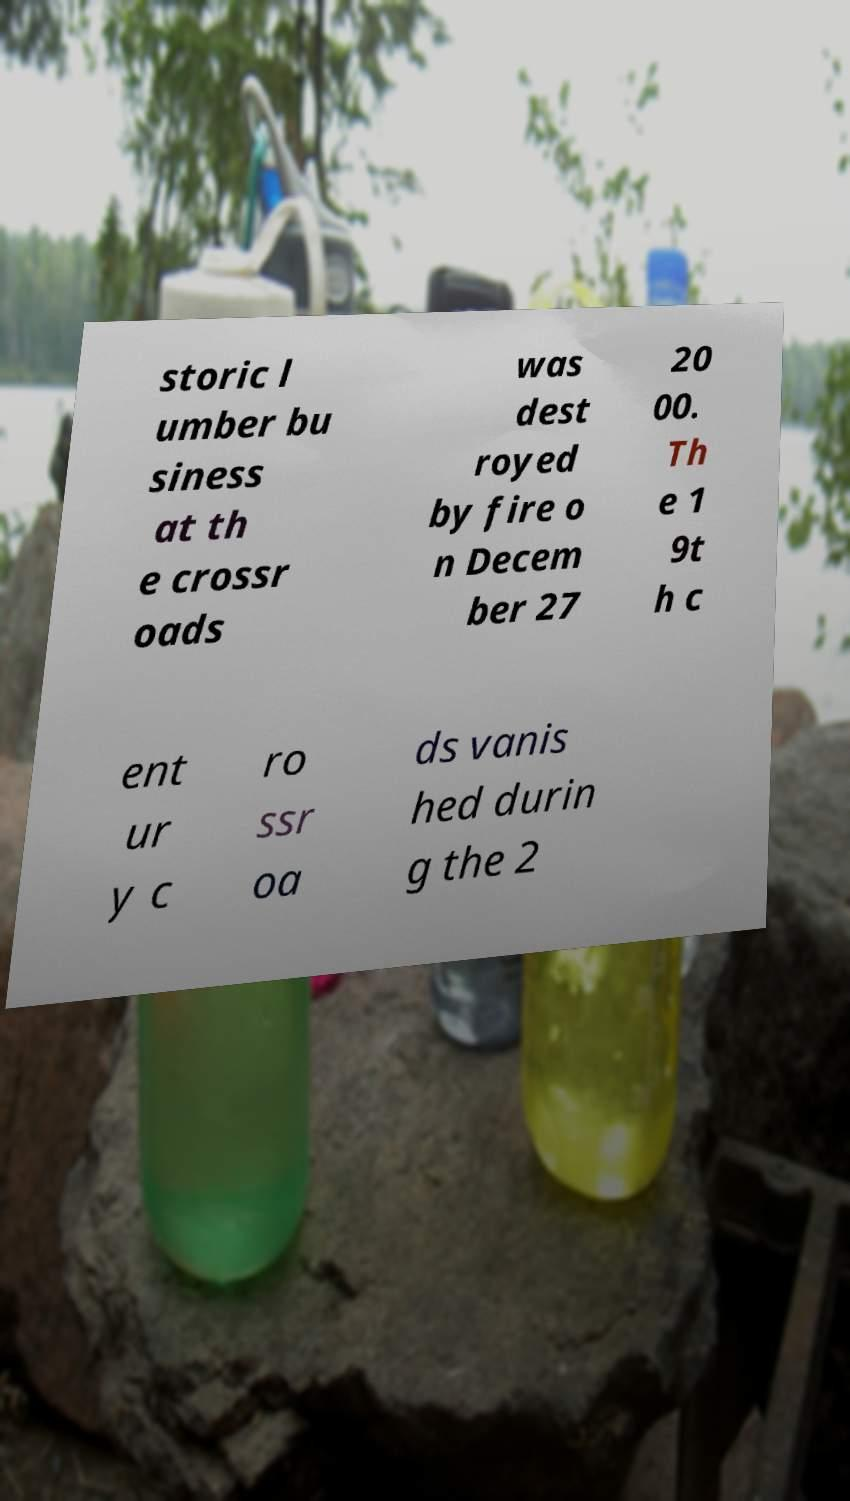For documentation purposes, I need the text within this image transcribed. Could you provide that? storic l umber bu siness at th e crossr oads was dest royed by fire o n Decem ber 27 20 00. Th e 1 9t h c ent ur y c ro ssr oa ds vanis hed durin g the 2 